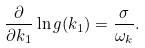<formula> <loc_0><loc_0><loc_500><loc_500>\frac { \partial } { \partial k _ { 1 } } \ln g ( k _ { 1 } ) = \frac { \sigma } { \omega _ { k } } .</formula> 